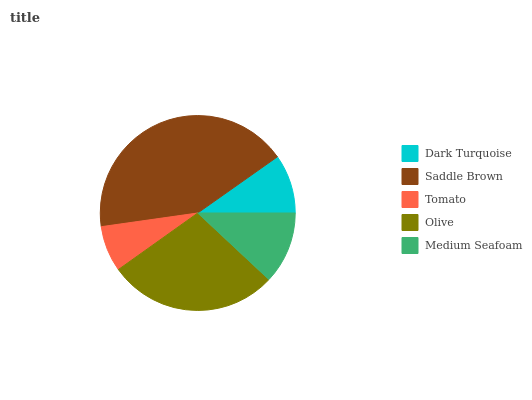Is Tomato the minimum?
Answer yes or no. Yes. Is Saddle Brown the maximum?
Answer yes or no. Yes. Is Saddle Brown the minimum?
Answer yes or no. No. Is Tomato the maximum?
Answer yes or no. No. Is Saddle Brown greater than Tomato?
Answer yes or no. Yes. Is Tomato less than Saddle Brown?
Answer yes or no. Yes. Is Tomato greater than Saddle Brown?
Answer yes or no. No. Is Saddle Brown less than Tomato?
Answer yes or no. No. Is Medium Seafoam the high median?
Answer yes or no. Yes. Is Medium Seafoam the low median?
Answer yes or no. Yes. Is Dark Turquoise the high median?
Answer yes or no. No. Is Tomato the low median?
Answer yes or no. No. 